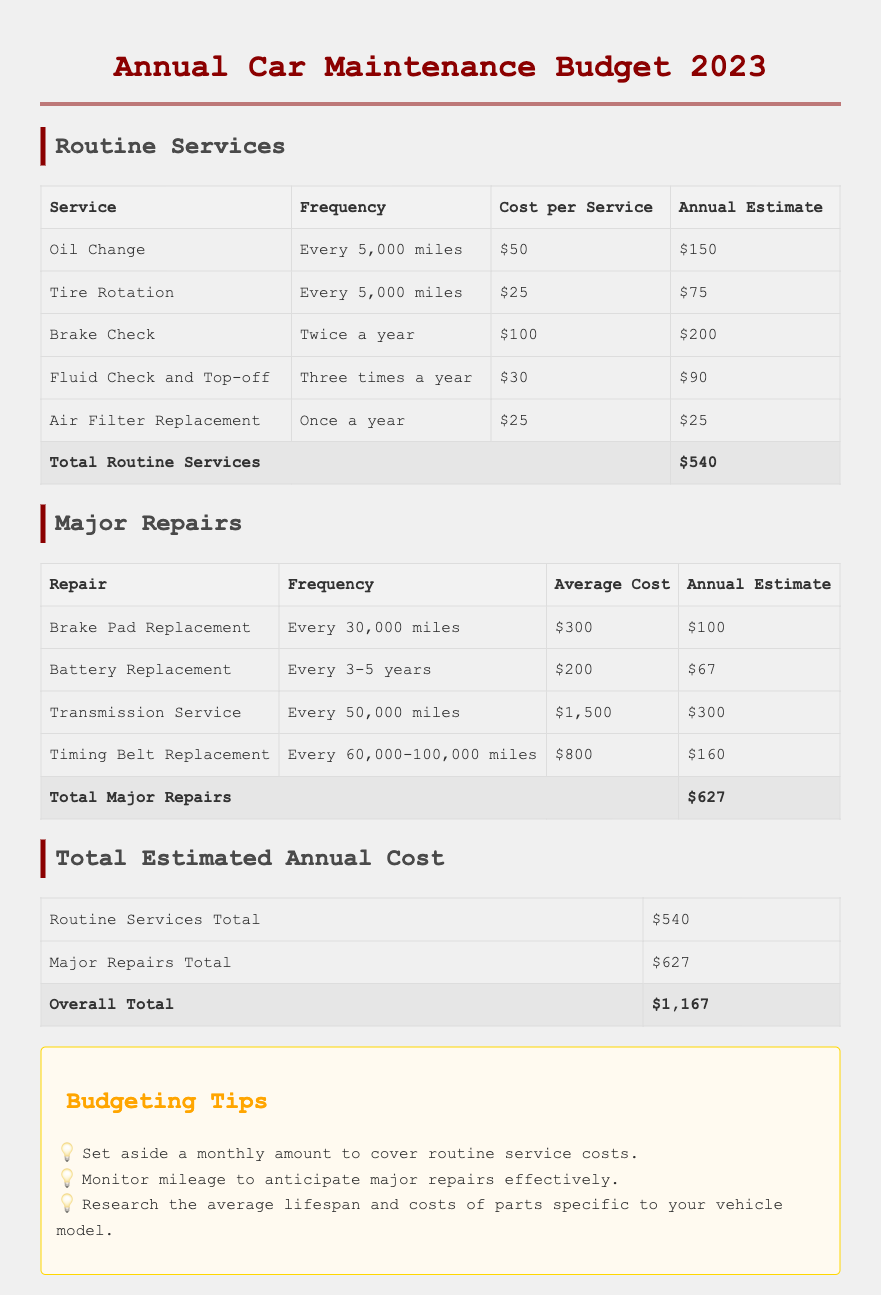what is the total estimate for routine services? The total estimate for routine services is the cumulative sum of all routine service costs, which is $540.
Answer: $540 what is the average cost of battery replacement? The average cost of battery replacement is specified in the major repairs section of the document, which is $200.
Answer: $200 how often should a fluid check and top-off be performed? The document states that fluid check and top-off should be performed three times a year, indicating its frequency.
Answer: Three times a year what is the total estimated annual cost for car maintenance? The overall total is calculated from both routine services and major repairs totals, leading to $1,167.
Answer: $1,167 how much is spent annually on brake pad replacement? The document lists the annual estimate for brake pad replacement as $100 under major repairs.
Answer: $100 what is the frequency for timing belt replacement? The document specifies that a timing belt replacement should occur every 60,000-100,000 miles, indicating its frequency.
Answer: Every 60,000-100,000 miles what is the total estimate for major repairs? The total estimate for major repairs is the cumulative sum of all major repair costs, which totals $627.
Answer: $627 what budgeting tip suggests monitoring mileage? The tip about monitoring mileage is intended to help anticipate major repairs effectively, as mentioned in the budgeting tips section.
Answer: Monitor mileage to anticipate major repairs effectively how much does an air filter replacement cost? The document indicates that the cost for an air filter replacement is $25 in the routine services section.
Answer: $25 